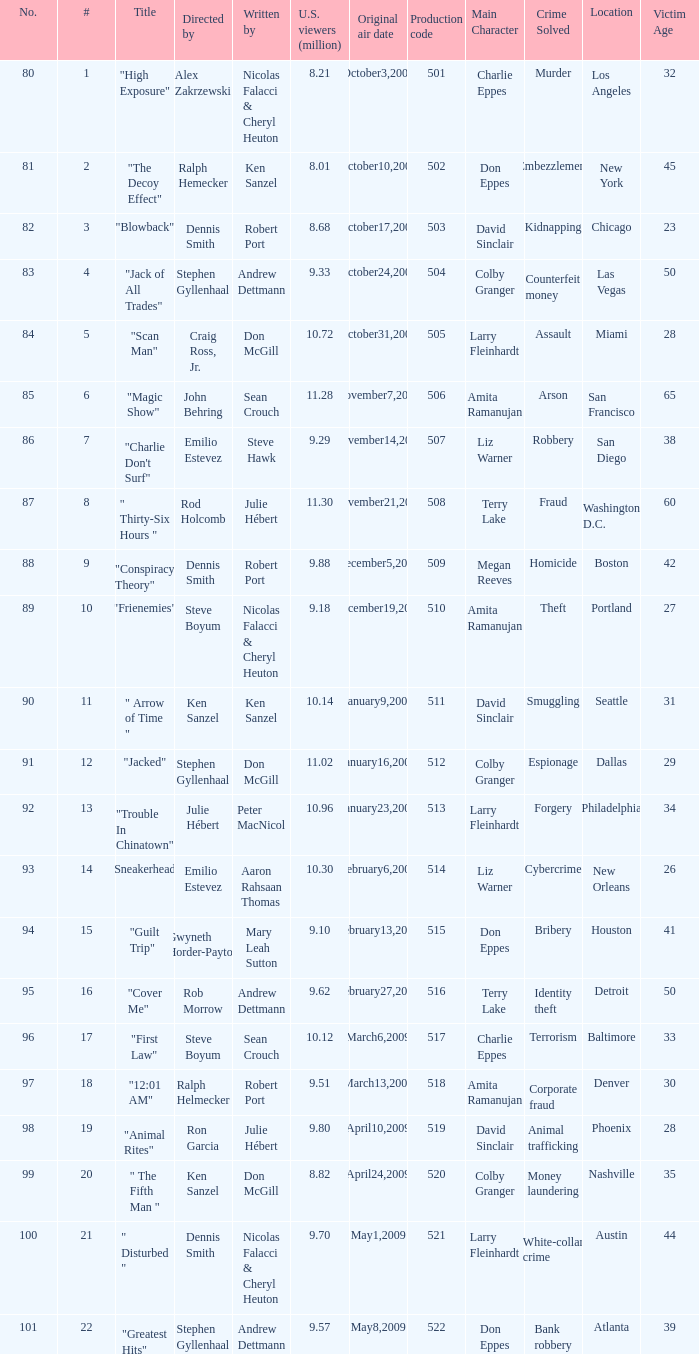For the episode attracting 9.18 million viewers in the u.s., what is its production code? 510.0. 